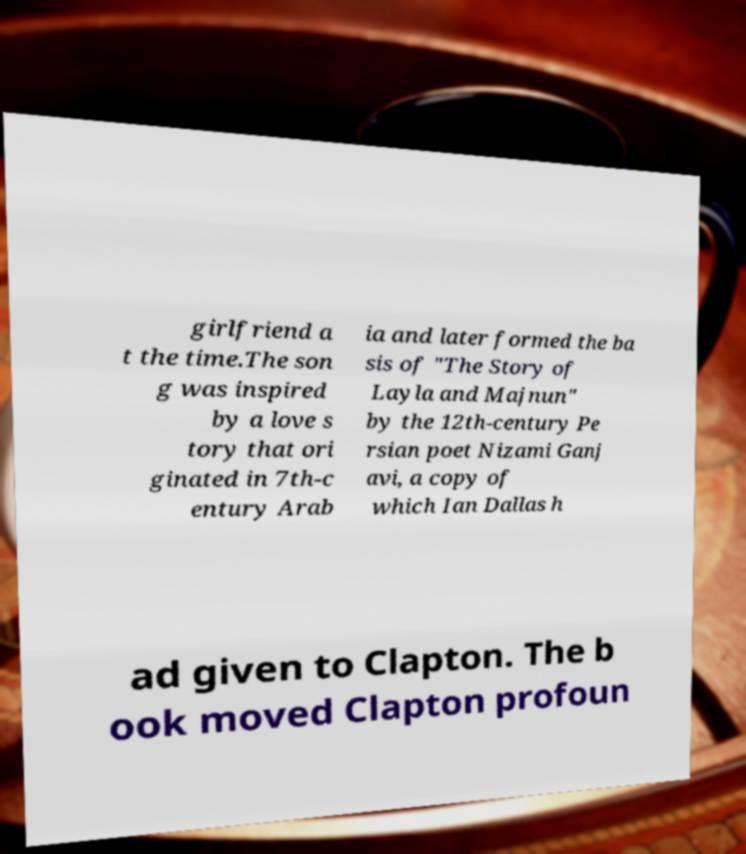Could you extract and type out the text from this image? girlfriend a t the time.The son g was inspired by a love s tory that ori ginated in 7th-c entury Arab ia and later formed the ba sis of "The Story of Layla and Majnun" by the 12th-century Pe rsian poet Nizami Ganj avi, a copy of which Ian Dallas h ad given to Clapton. The b ook moved Clapton profoun 